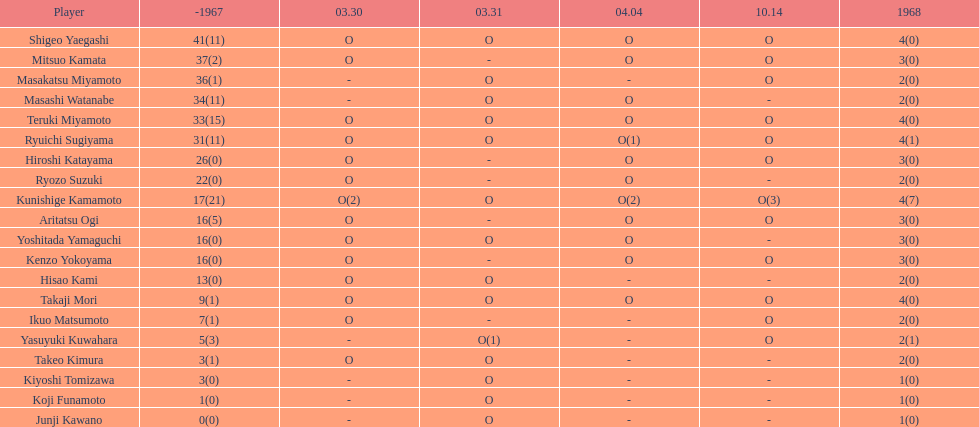Did mitsuo kamata have more than 40 total points? No. 